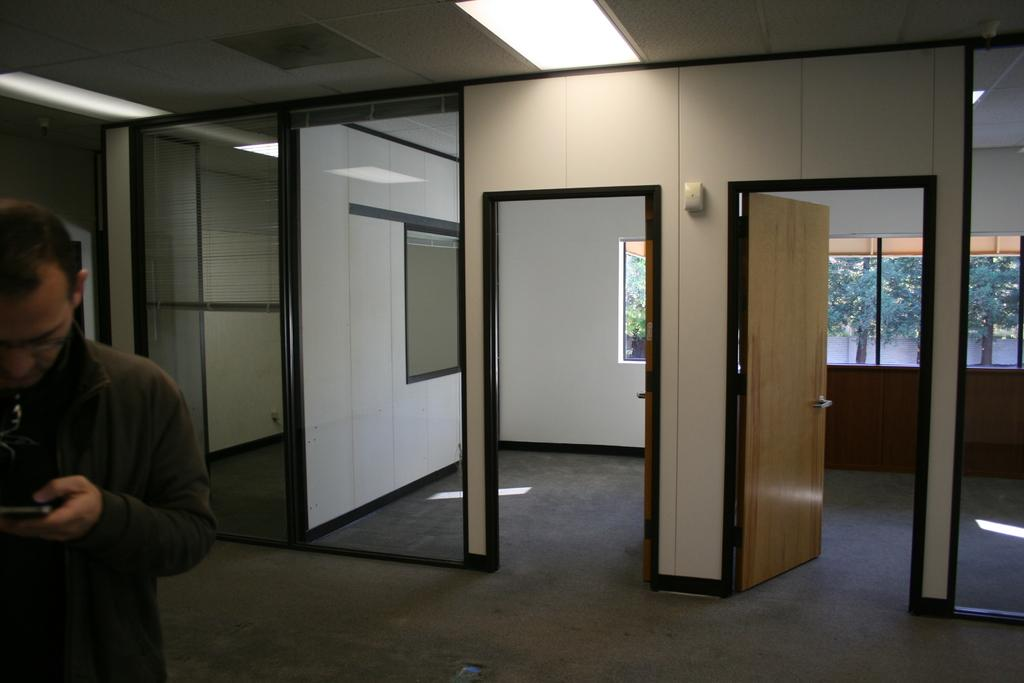What is the person in the image doing? The person is standing and holding a mobile in the image. What can be seen in the background of the image? There are brown doors, glass windows, and trees with green color in the background. What type of payment is being made by the person in the image? There is no indication of any payment being made in the image; the person is simply holding a mobile. 